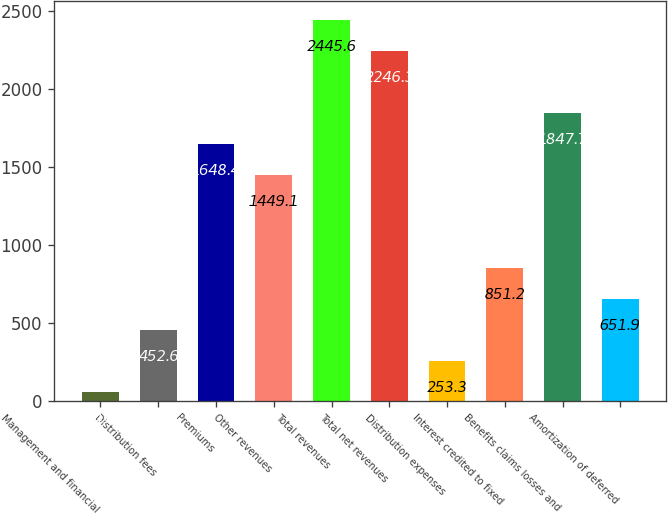Convert chart. <chart><loc_0><loc_0><loc_500><loc_500><bar_chart><fcel>Management and financial<fcel>Distribution fees<fcel>Premiums<fcel>Other revenues<fcel>Total revenues<fcel>Total net revenues<fcel>Distribution expenses<fcel>Interest credited to fixed<fcel>Benefits claims losses and<fcel>Amortization of deferred<nl><fcel>54<fcel>452.6<fcel>1648.4<fcel>1449.1<fcel>2445.6<fcel>2246.3<fcel>253.3<fcel>851.2<fcel>1847.7<fcel>651.9<nl></chart> 